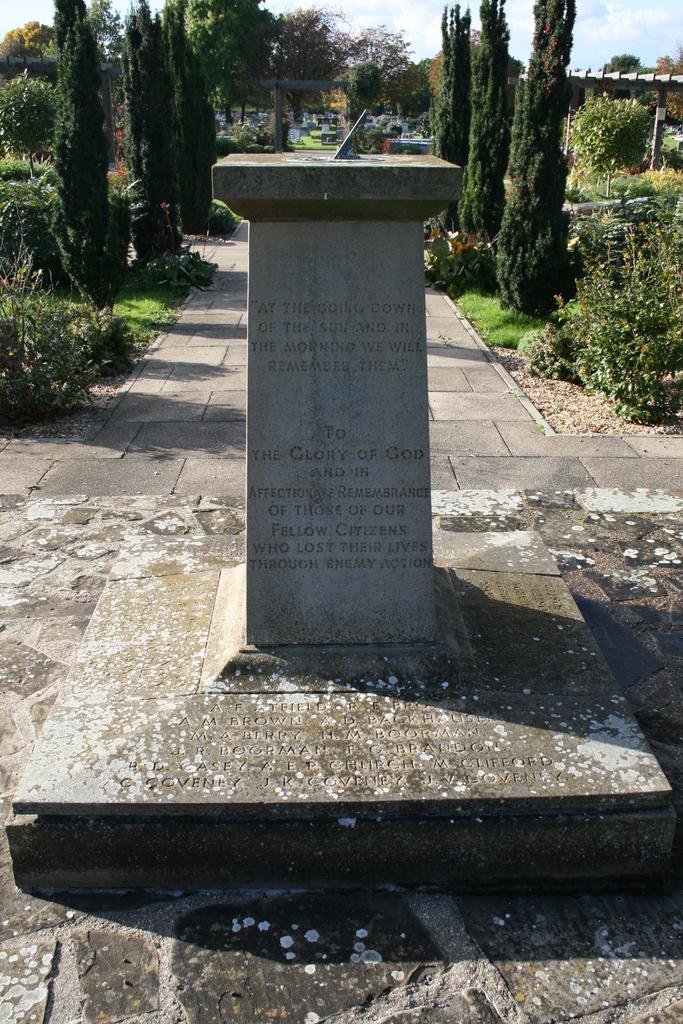Please provide a concise description of this image. In this image, we can see a pillar with some text. Here we can see a walkway. Background there are so many trees, plants, poles, arch and sky. 